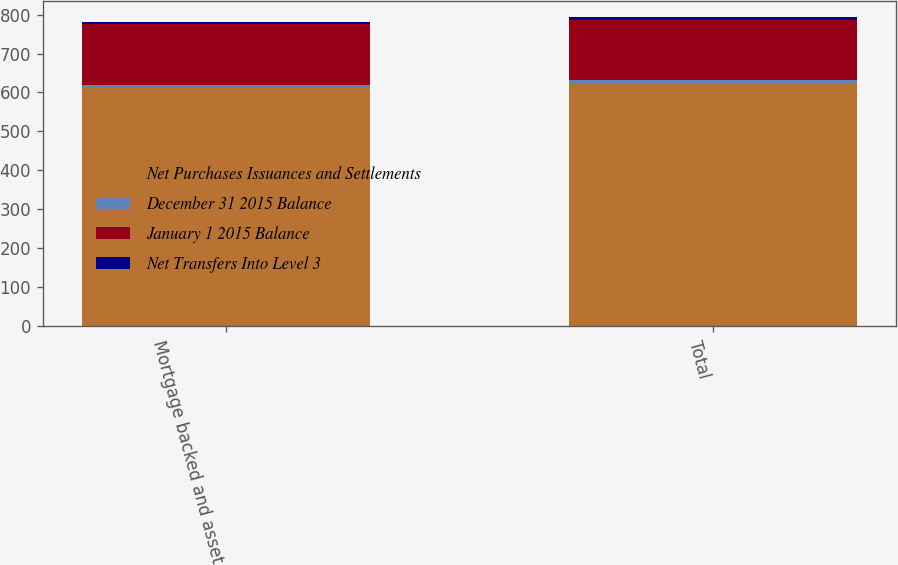<chart> <loc_0><loc_0><loc_500><loc_500><stacked_bar_chart><ecel><fcel>Mortgage backed and asset<fcel>Total<nl><fcel>Net Purchases Issuances and Settlements<fcel>611<fcel>621<nl><fcel>December 31 2015 Balance<fcel>9<fcel>12<nl><fcel>January 1 2015 Balance<fcel>157<fcel>153<nl><fcel>Net Transfers Into Level 3<fcel>3<fcel>8<nl></chart> 